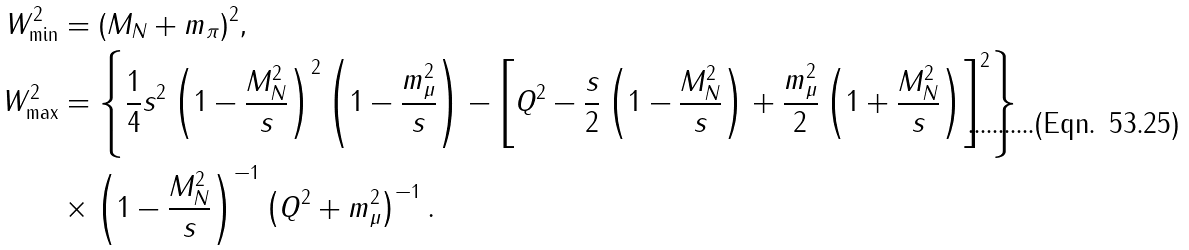<formula> <loc_0><loc_0><loc_500><loc_500>W ^ { 2 } _ { \min } & = ( M _ { N } + m _ { \pi } ) ^ { 2 } , \\ W ^ { 2 } _ { \max } & = \left \{ \frac { 1 } { 4 } s ^ { 2 } \left ( 1 - \frac { M _ { N } ^ { 2 } } { s } \right ) ^ { 2 } \left ( 1 - \frac { m _ { \mu } ^ { 2 } } { s } \right ) - \left [ Q ^ { 2 } - \frac { s } { 2 } \left ( 1 - \frac { M _ { N } ^ { 2 } } { s } \right ) + \frac { m _ { \mu } ^ { 2 } } { 2 } \left ( 1 + \frac { M _ { N } ^ { 2 } } { s } \right ) \right ] ^ { 2 } \right \} \\ & \times \left ( 1 - \frac { M _ { N } ^ { 2 } } { s } \right ) ^ { - 1 } \left ( Q ^ { 2 } + m _ { \mu } ^ { 2 } \right ) ^ { - 1 } .</formula> 